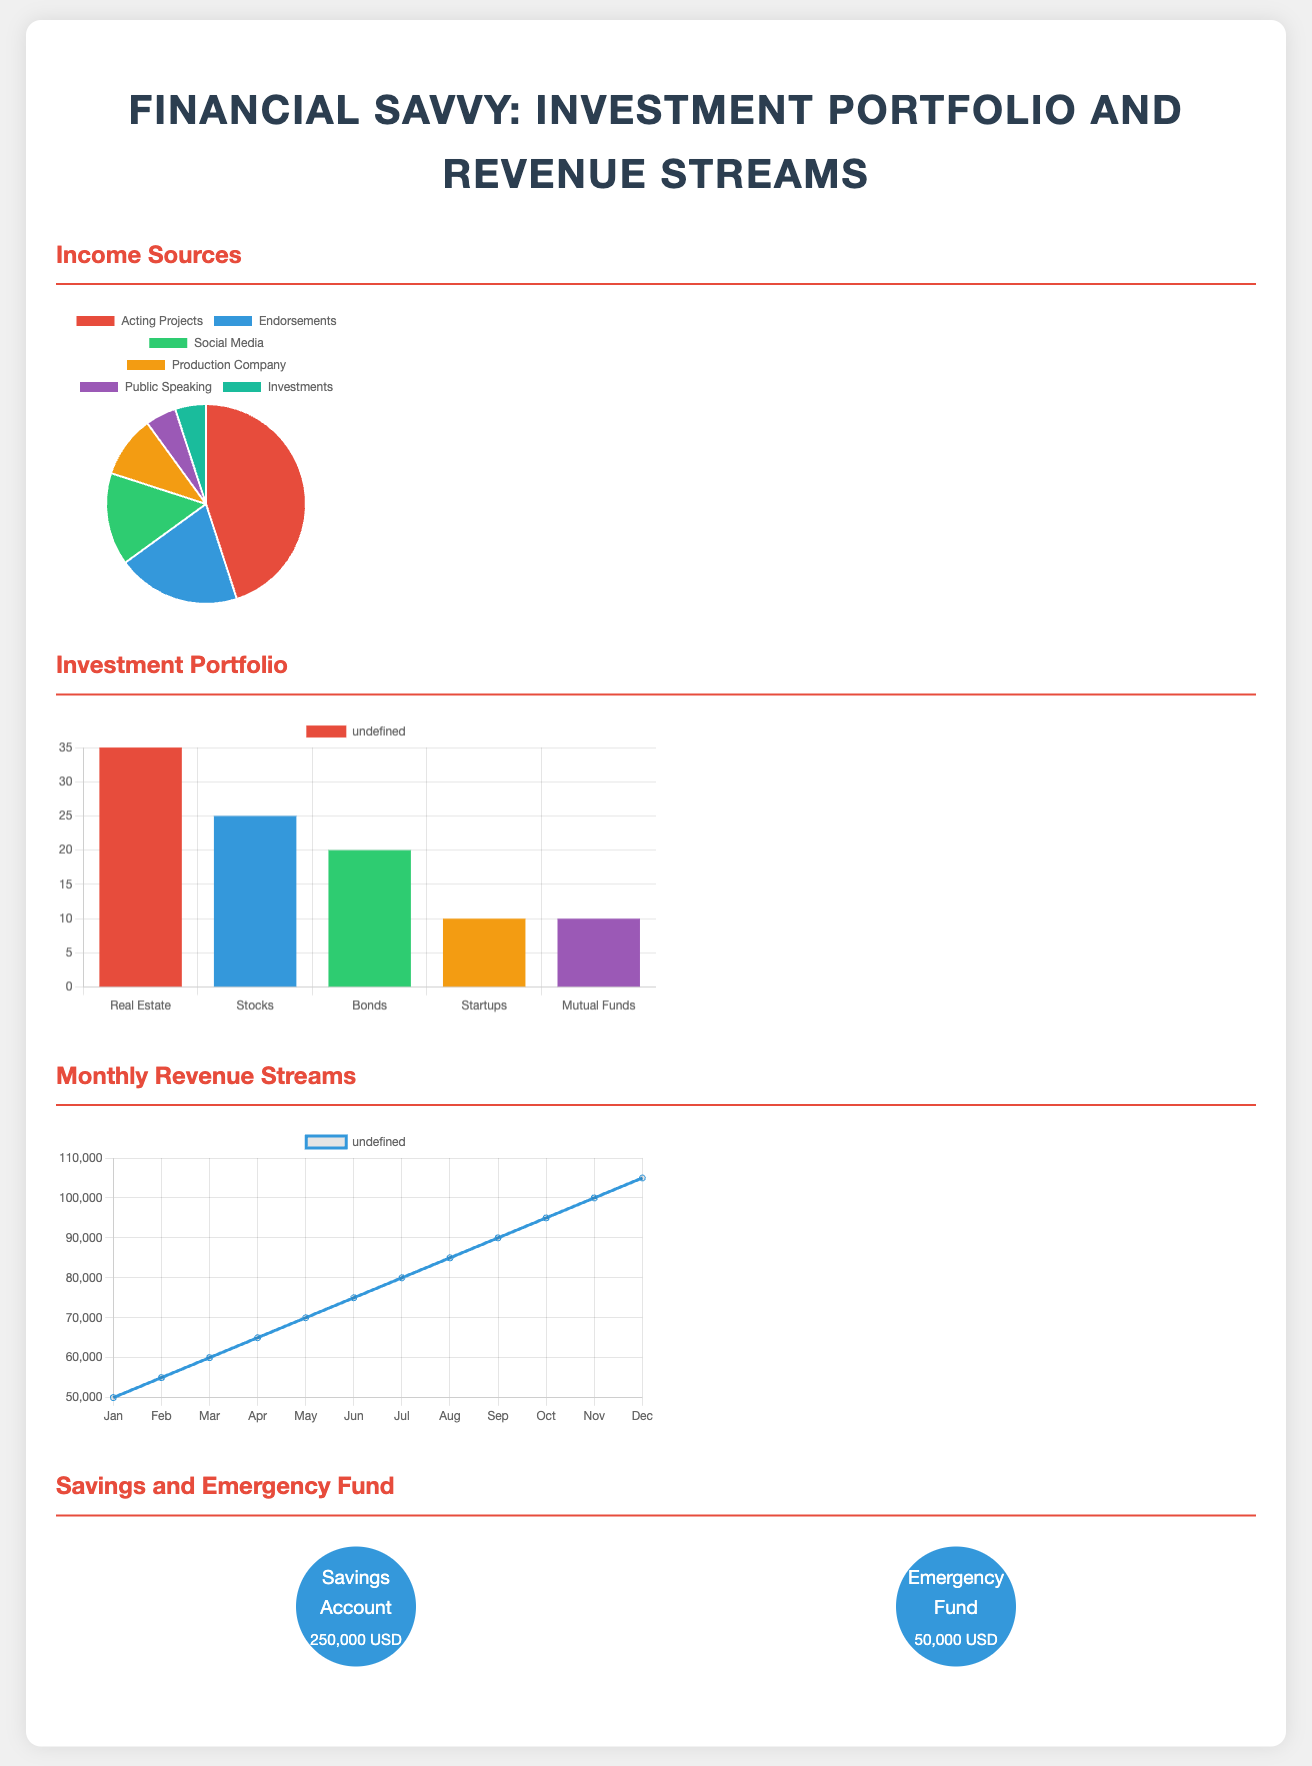What is the largest income source? The largest income source is represented in the pie chart as 'Acting Projects,' which has the highest percentage among all categories.
Answer: Acting Projects What percentage of the investment portfolio is allocated to real estate? The percentage allocated to real estate can be found in the bar chart of the investment portfolio, which shows a value of 35%.
Answer: 35% Which revenue stream shows a consistent increase over the months? The line chart depicting monthly revenue streams indicates that the revenue shows a consistent increase throughout the year from January to December.
Answer: Yes What is the total amount in the savings account? The savings and emergency fund section specifies that the savings account holds $250,000.
Answer: 250,000 USD How many income sources are listed in the infographic? The income sources section of the pie chart lists a total of six different income sources.
Answer: 6 Which investment has the lowest allocation in the portfolio? The investment portfolio bar chart reveals that 'Startups' and 'Mutual Funds' both have the lowest allocation at 10%.
Answer: Startups, Mutual Funds What is the monthly revenue in June? The line chart indicates the monthly revenue in June is represented by the data point which shows a value of $75,000.
Answer: $75,000 What color represents endorsements in the income chart? The color associated with endorsements in the income sources pie chart is blue.
Answer: Blue 